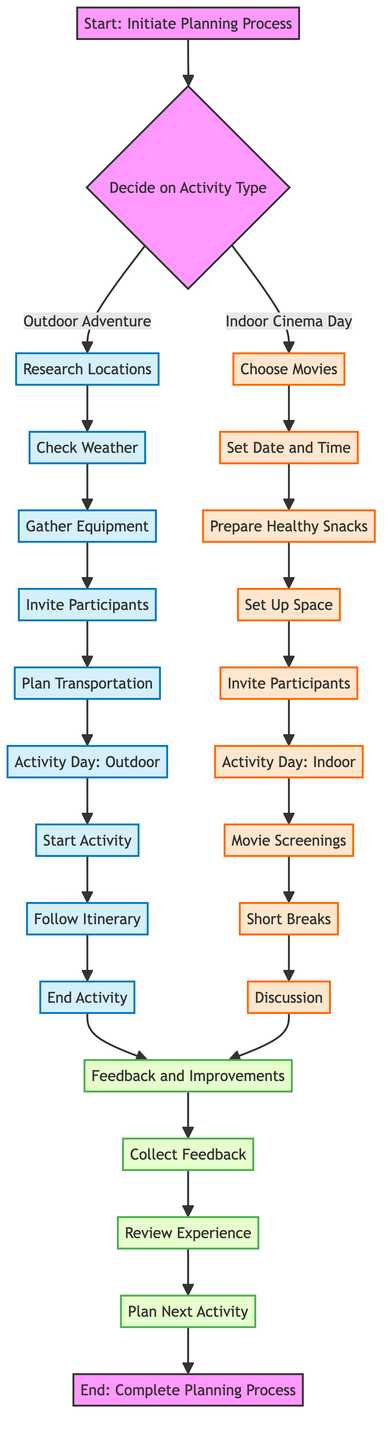what is the first step in the workflow? The first step in the workflow is "Initiate Planning Process," as indicated by the starting node of the flowchart.
Answer: Initiate Planning Process how many main activity types are there in the diagram? The diagram presents two main activity types: "Outdoor Adventure" and "Indoor Cinema Day,” which can be identified in the decision node.
Answer: 2 what do you need to do after inviting participants for an outdoor adventure? After inviting participants for an outdoor adventure, the next step is to "Plan Transportation," which follows in the flowchart after gathering participants.
Answer: Plan Transportation which node follows "Prepare Snacks" in the indoor cinema day segment? In the indoor cinema day segment, the node that follows "Prepare Snacks" is "Set Up Space," as per the sequence in the chart.
Answer: Set Up Space what happens during the "Activity Day" for outdoor adventures? During the "Activity Day" for outdoor adventures, the steps include "Start Activity," "Follow Itinerary," and "End Activity," as outlined in the respective section of the diagram.
Answer: Start Activity how does the feedback process begin after either activity? The feedback process begins with "Collect Feedback," which is the first node in the feedback section after all activities are completed, making it clear that feedback collection starts afterward.
Answer: Collect Feedback what is the purpose of the "Discussion" step in an indoor cinema day? The "Discussion" step in an indoor cinema day serves to reflect on themes and impressions after the movie screenings, fostering engagement and thought.
Answer: Have a post-movie discussion which step follows "Review Experience" in the feedback section? In the feedback section, the step that follows "Review Experience" is "Plan Next Activity," indicating the progression toward planning future activities based on the current experience.
Answer: Plan Next Activity what is a common node for both activities in the workflow? A common node for both activities in the workflow is "Invite Participants," which appears in both the outdoor adventure and indoor cinema day sections.
Answer: Invite Participants 